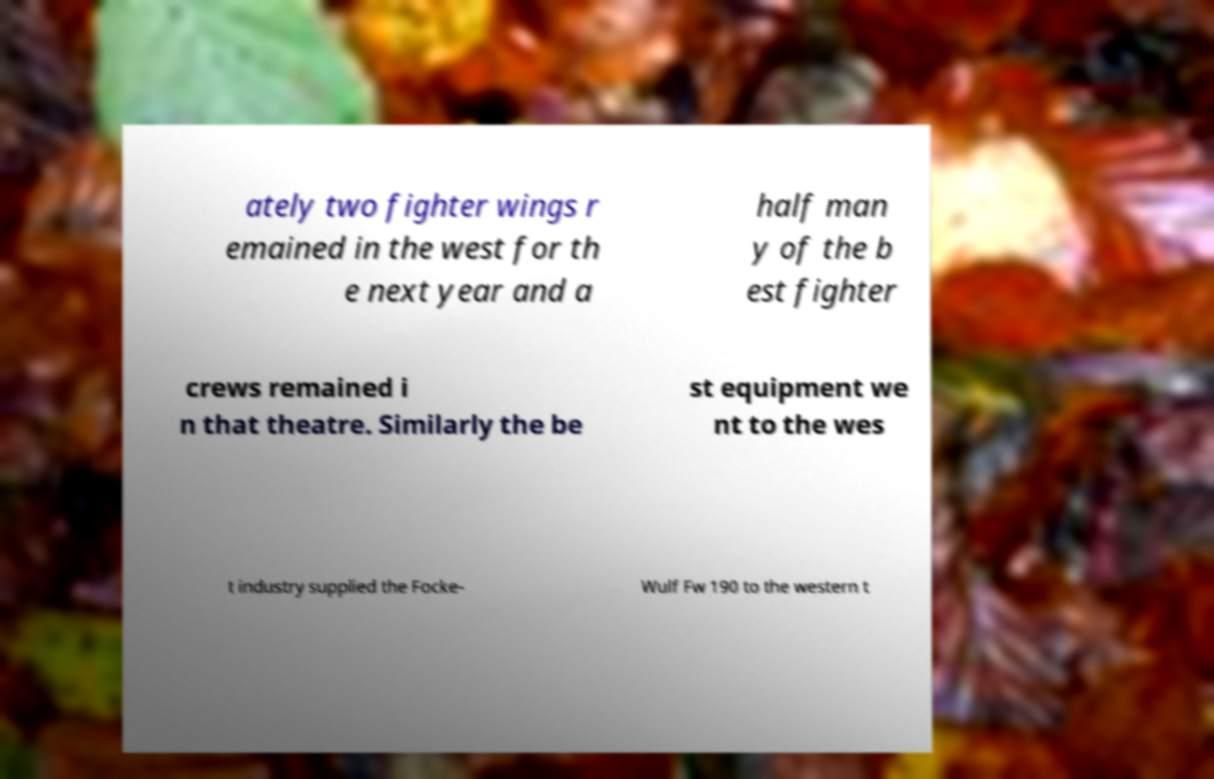What messages or text are displayed in this image? I need them in a readable, typed format. ately two fighter wings r emained in the west for th e next year and a half man y of the b est fighter crews remained i n that theatre. Similarly the be st equipment we nt to the wes t industry supplied the Focke- Wulf Fw 190 to the western t 